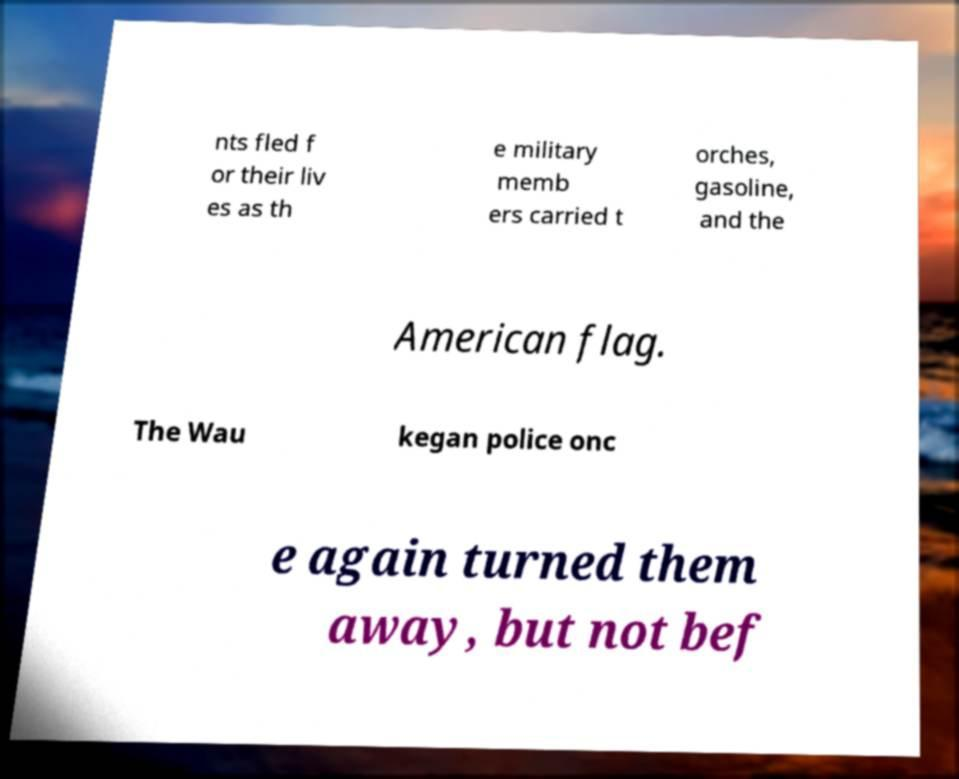Can you accurately transcribe the text from the provided image for me? nts fled f or their liv es as th e military memb ers carried t orches, gasoline, and the American flag. The Wau kegan police onc e again turned them away, but not bef 